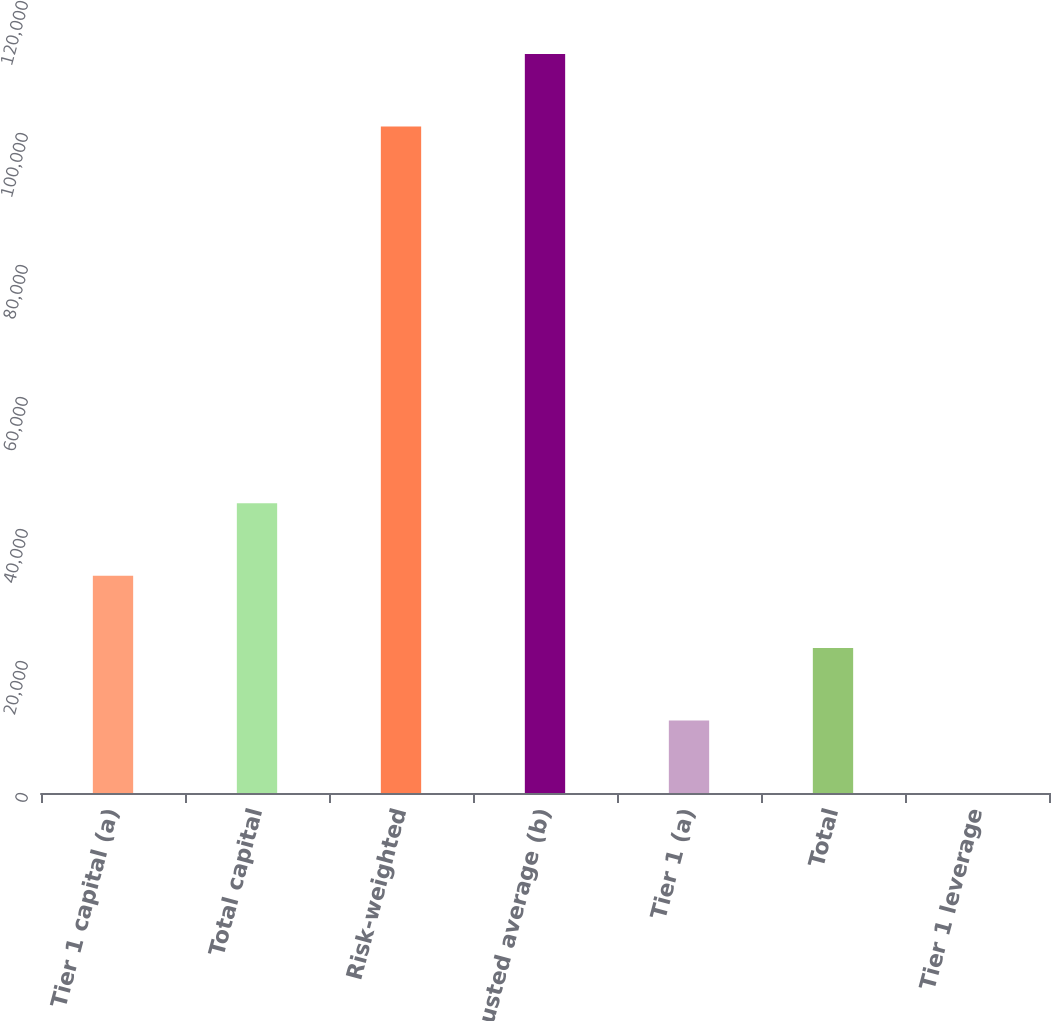Convert chart to OTSL. <chart><loc_0><loc_0><loc_500><loc_500><bar_chart><fcel>Tier 1 capital (a)<fcel>Total capital<fcel>Risk-weighted<fcel>Adjusted average (b)<fcel>Tier 1 (a)<fcel>Total<fcel>Tier 1 leverage<nl><fcel>32927.6<fcel>43899.5<fcel>100990<fcel>111962<fcel>10983.7<fcel>21955.6<fcel>11.8<nl></chart> 